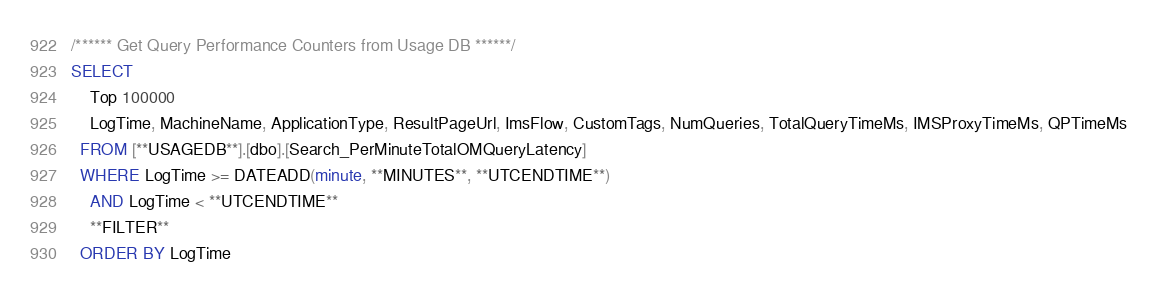Convert code to text. <code><loc_0><loc_0><loc_500><loc_500><_SQL_>/****** Get Query Performance Counters from Usage DB ******/
SELECT 
	Top 100000
	LogTime, MachineName, ApplicationType, ResultPageUrl, ImsFlow, CustomTags, NumQueries, TotalQueryTimeMs, IMSProxyTimeMs, QPTimeMs
  FROM [**USAGEDB**].[dbo].[Search_PerMinuteTotalOMQueryLatency]
  WHERE LogTime >= DATEADD(minute, **MINUTES**, **UTCENDTIME**)
    AND LogTime < **UTCENDTIME**
    **FILTER**
  ORDER BY LogTime</code> 